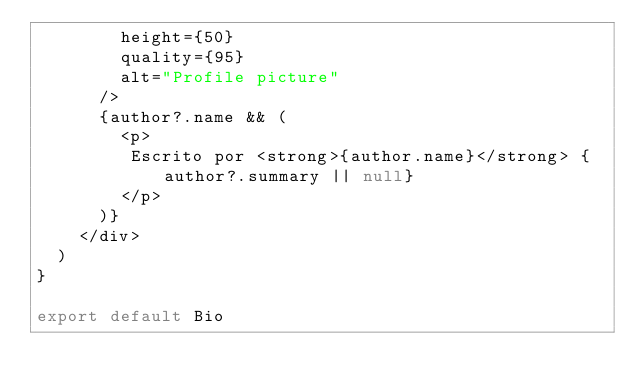Convert code to text. <code><loc_0><loc_0><loc_500><loc_500><_JavaScript_>        height={50}
        quality={95}
        alt="Profile picture"
      />
      {author?.name && (
        <p>
         Escrito por <strong>{author.name}</strong> {author?.summary || null}
        </p>
      )}
    </div>
  )
}

export default Bio
</code> 